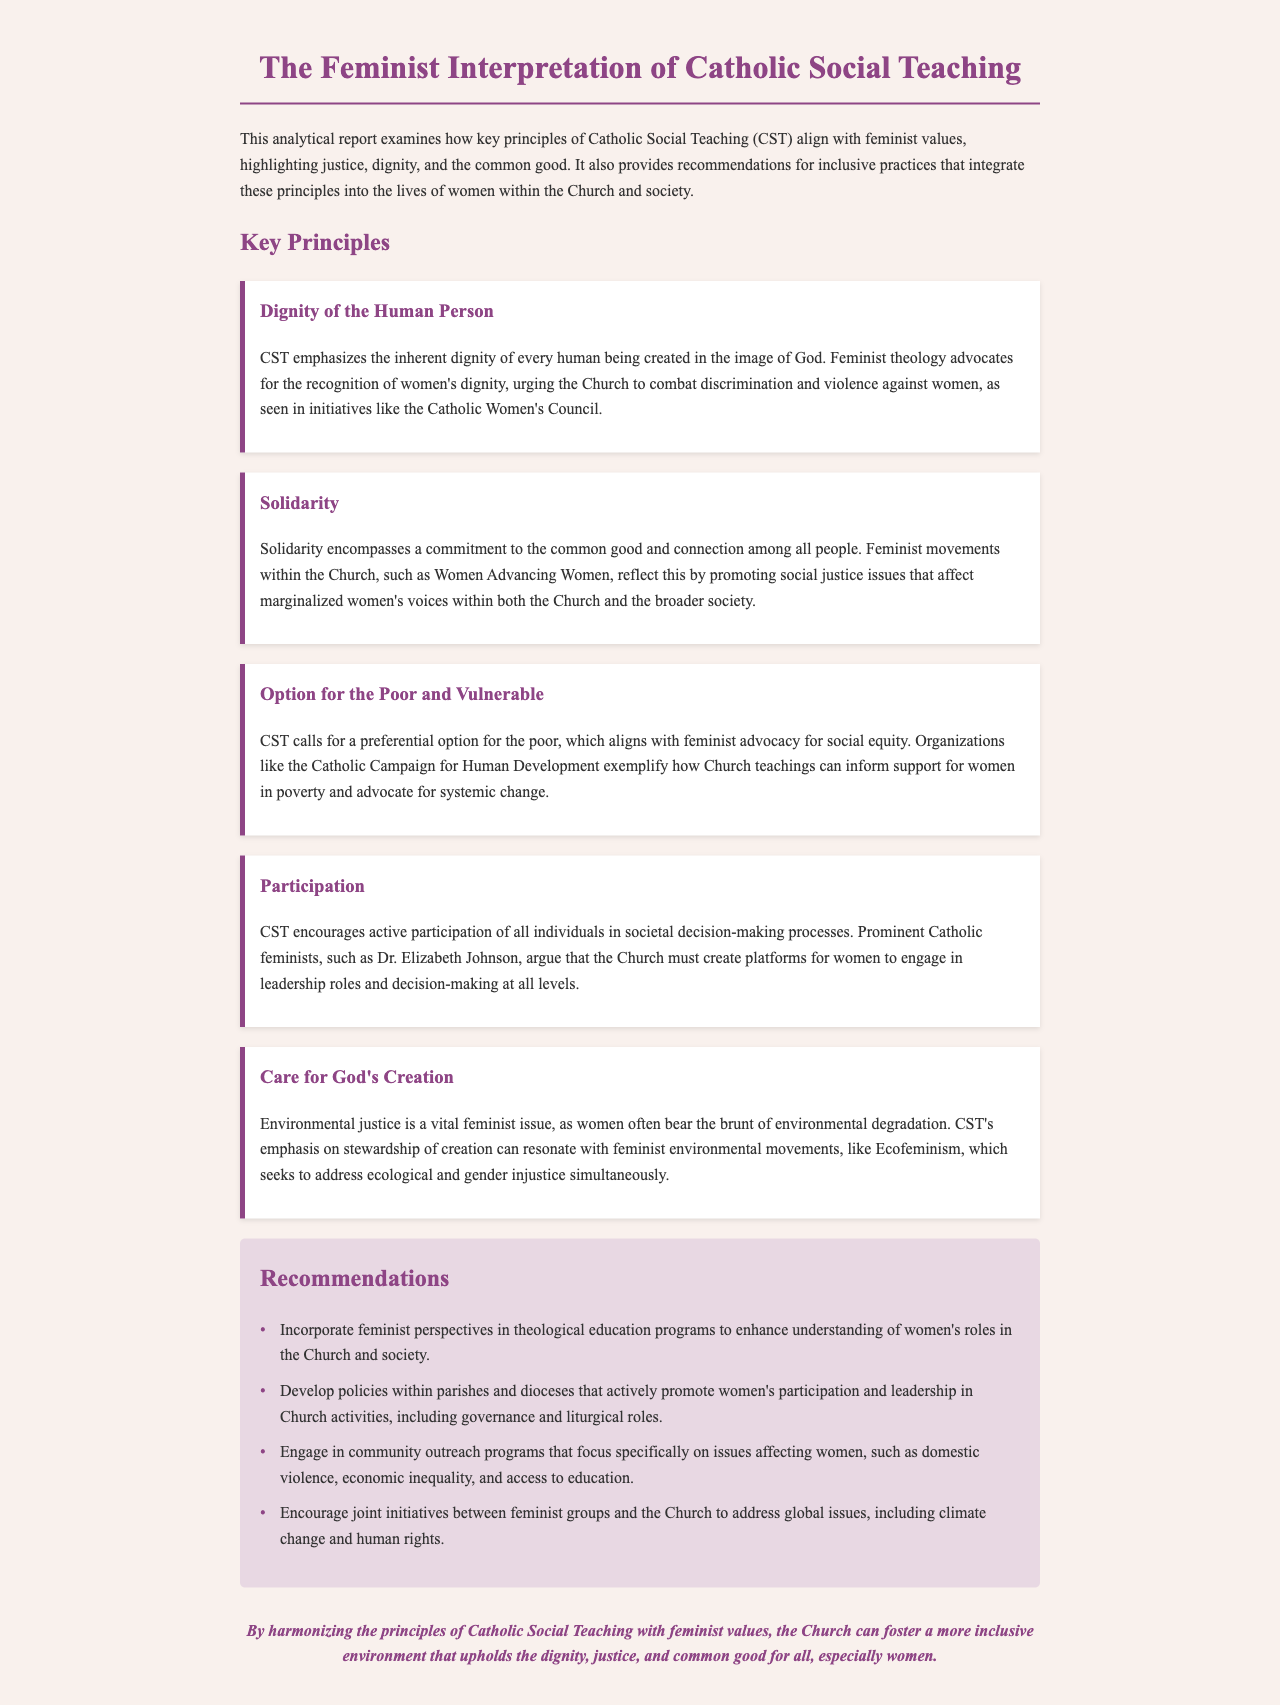What is the title of the report? The title is the main heading of the document, summarizing its focus and content.
Answer: The Feminist Interpretation of Catholic Social Teaching What principle emphasizes the inherent dignity of every human being? This principle focuses on the value of each individual as created in the image of God.
Answer: Dignity of the Human Person Which feminist movement is mentioned in relation to solidarity? This movement promotes social justice and supports marginalized women's voices.
Answer: Women Advancing Women What is the preferred option in Catholic Social Teaching for those in need? This principle advocates for a focused effort to support disadvantaged groups within society.
Answer: Option for the Poor and Vulnerable How many recommendations are provided in the report? The document lists a specific number of actionable suggestions for inclusive practices.
Answer: Four Who is a prominent Catholic feminist mentioned in the report? This individual is referenced as advocating for women's leadership and decision-making roles in the Church.
Answer: Dr. Elizabeth Johnson What environmental issue is highlighted in relation to feminist concerns? This issue relates to the adverse effects of ecological degradation on women, linking feminist and environmental advocacy.
Answer: Environmental justice What color is used for the report's background? This detail pertains to the specific aesthetic design choice for the document's visual presentation.
Answer: #f9f1ed What type of document is this? This classification describes the nature or format of the content being presented.
Answer: Analytical report 